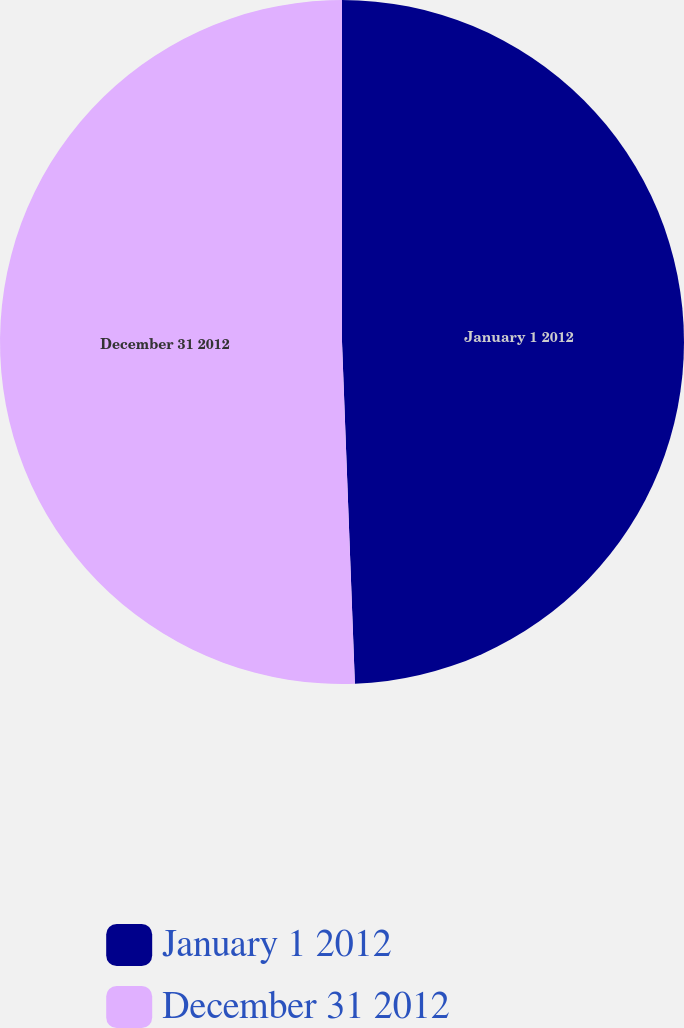Convert chart. <chart><loc_0><loc_0><loc_500><loc_500><pie_chart><fcel>January 1 2012<fcel>December 31 2012<nl><fcel>49.4%<fcel>50.6%<nl></chart> 